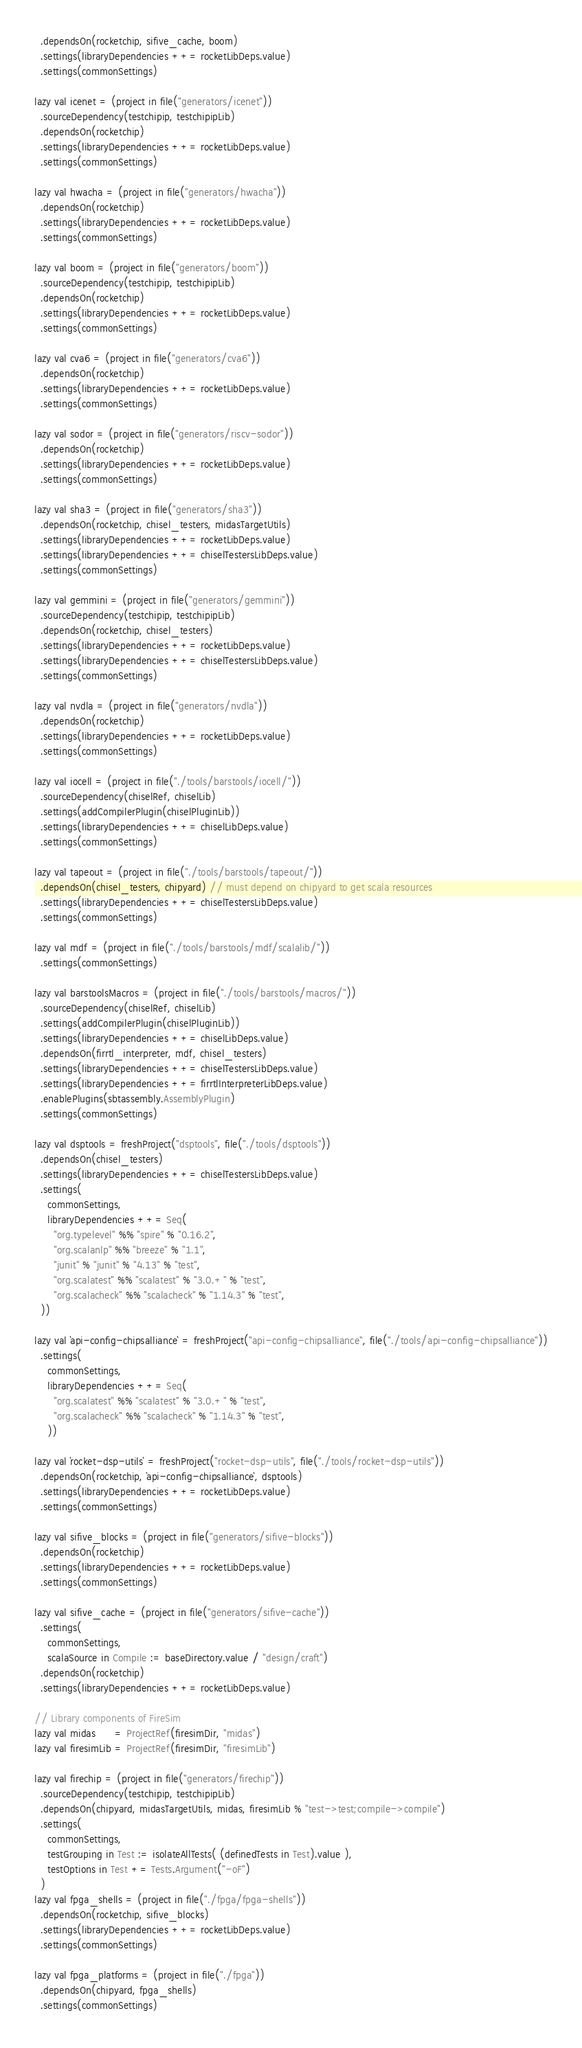<code> <loc_0><loc_0><loc_500><loc_500><_Scala_>  .dependsOn(rocketchip, sifive_cache, boom)
  .settings(libraryDependencies ++= rocketLibDeps.value)
  .settings(commonSettings)

lazy val icenet = (project in file("generators/icenet"))
  .sourceDependency(testchipip, testchipipLib)
  .dependsOn(rocketchip)
  .settings(libraryDependencies ++= rocketLibDeps.value)
  .settings(commonSettings)

lazy val hwacha = (project in file("generators/hwacha"))
  .dependsOn(rocketchip)
  .settings(libraryDependencies ++= rocketLibDeps.value)
  .settings(commonSettings)

lazy val boom = (project in file("generators/boom"))
  .sourceDependency(testchipip, testchipipLib)
  .dependsOn(rocketchip)
  .settings(libraryDependencies ++= rocketLibDeps.value)
  .settings(commonSettings)

lazy val cva6 = (project in file("generators/cva6"))
  .dependsOn(rocketchip)
  .settings(libraryDependencies ++= rocketLibDeps.value)
  .settings(commonSettings)

lazy val sodor = (project in file("generators/riscv-sodor"))
  .dependsOn(rocketchip)
  .settings(libraryDependencies ++= rocketLibDeps.value)
  .settings(commonSettings)

lazy val sha3 = (project in file("generators/sha3"))
  .dependsOn(rocketchip, chisel_testers, midasTargetUtils)
  .settings(libraryDependencies ++= rocketLibDeps.value)
  .settings(libraryDependencies ++= chiselTestersLibDeps.value)
  .settings(commonSettings)

lazy val gemmini = (project in file("generators/gemmini"))
  .sourceDependency(testchipip, testchipipLib)
  .dependsOn(rocketchip, chisel_testers)
  .settings(libraryDependencies ++= rocketLibDeps.value)
  .settings(libraryDependencies ++= chiselTestersLibDeps.value)
  .settings(commonSettings)

lazy val nvdla = (project in file("generators/nvdla"))
  .dependsOn(rocketchip)
  .settings(libraryDependencies ++= rocketLibDeps.value)
  .settings(commonSettings)

lazy val iocell = (project in file("./tools/barstools/iocell/"))
  .sourceDependency(chiselRef, chiselLib)
  .settings(addCompilerPlugin(chiselPluginLib))
  .settings(libraryDependencies ++= chiselLibDeps.value)
  .settings(commonSettings)

lazy val tapeout = (project in file("./tools/barstools/tapeout/"))
  .dependsOn(chisel_testers, chipyard) // must depend on chipyard to get scala resources
  .settings(libraryDependencies ++= chiselTestersLibDeps.value)
  .settings(commonSettings)

lazy val mdf = (project in file("./tools/barstools/mdf/scalalib/"))
  .settings(commonSettings)

lazy val barstoolsMacros = (project in file("./tools/barstools/macros/"))
  .sourceDependency(chiselRef, chiselLib)
  .settings(addCompilerPlugin(chiselPluginLib))
  .settings(libraryDependencies ++= chiselLibDeps.value)
  .dependsOn(firrtl_interpreter, mdf, chisel_testers)
  .settings(libraryDependencies ++= chiselTestersLibDeps.value)
  .settings(libraryDependencies ++= firrtlInterpreterLibDeps.value)
  .enablePlugins(sbtassembly.AssemblyPlugin)
  .settings(commonSettings)

lazy val dsptools = freshProject("dsptools", file("./tools/dsptools"))
  .dependsOn(chisel_testers)
  .settings(libraryDependencies ++= chiselTestersLibDeps.value)
  .settings(
    commonSettings,
    libraryDependencies ++= Seq(
      "org.typelevel" %% "spire" % "0.16.2",
      "org.scalanlp" %% "breeze" % "1.1",
      "junit" % "junit" % "4.13" % "test",
      "org.scalatest" %% "scalatest" % "3.0.+" % "test",
      "org.scalacheck" %% "scalacheck" % "1.14.3" % "test",
  ))

lazy val `api-config-chipsalliance` = freshProject("api-config-chipsalliance", file("./tools/api-config-chipsalliance"))
  .settings(
    commonSettings,
    libraryDependencies ++= Seq(
      "org.scalatest" %% "scalatest" % "3.0.+" % "test",
      "org.scalacheck" %% "scalacheck" % "1.14.3" % "test",
    ))

lazy val `rocket-dsp-utils` = freshProject("rocket-dsp-utils", file("./tools/rocket-dsp-utils"))
  .dependsOn(rocketchip, `api-config-chipsalliance`, dsptools)
  .settings(libraryDependencies ++= rocketLibDeps.value)
  .settings(commonSettings)

lazy val sifive_blocks = (project in file("generators/sifive-blocks"))
  .dependsOn(rocketchip)
  .settings(libraryDependencies ++= rocketLibDeps.value)
  .settings(commonSettings)

lazy val sifive_cache = (project in file("generators/sifive-cache"))
  .settings(
    commonSettings,
    scalaSource in Compile := baseDirectory.value / "design/craft")
  .dependsOn(rocketchip)
  .settings(libraryDependencies ++= rocketLibDeps.value)

// Library components of FireSim
lazy val midas      = ProjectRef(firesimDir, "midas")
lazy val firesimLib = ProjectRef(firesimDir, "firesimLib")

lazy val firechip = (project in file("generators/firechip"))
  .sourceDependency(testchipip, testchipipLib)
  .dependsOn(chipyard, midasTargetUtils, midas, firesimLib % "test->test;compile->compile")
  .settings(
    commonSettings,
    testGrouping in Test := isolateAllTests( (definedTests in Test).value ),
    testOptions in Test += Tests.Argument("-oF")
  )
lazy val fpga_shells = (project in file("./fpga/fpga-shells"))
  .dependsOn(rocketchip, sifive_blocks)
  .settings(libraryDependencies ++= rocketLibDeps.value)
  .settings(commonSettings)

lazy val fpga_platforms = (project in file("./fpga"))
  .dependsOn(chipyard, fpga_shells)
  .settings(commonSettings)
</code> 